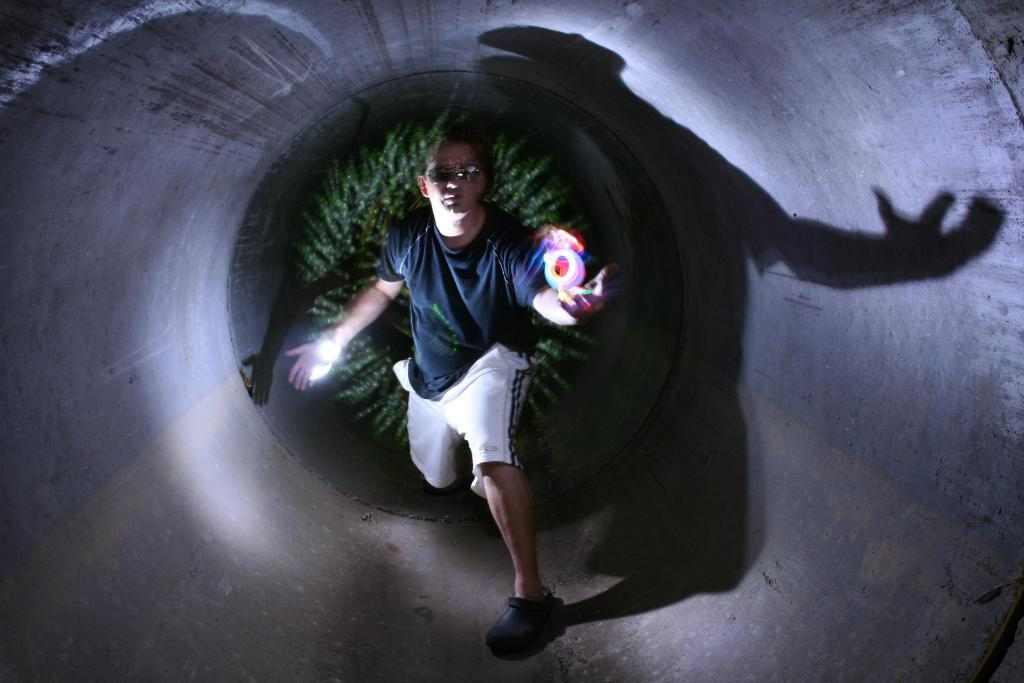Who is present in the image? There is a man in the image. What is the man wearing on his face? The man is wearing goggles. What type of footwear is the man wearing? The man is wearing shoes. What is the man's posture in the image? The man is standing. What can be seen in the background of the image? There are trees in the background of the image. What type of hospital is depicted in the image? There is no hospital present in the image; it features a man wearing goggles and shoes, standing amidst objects and trees. What government policies are being discussed in the image? There is no discussion of government policies in the image; it focuses on a man and his surroundings. 